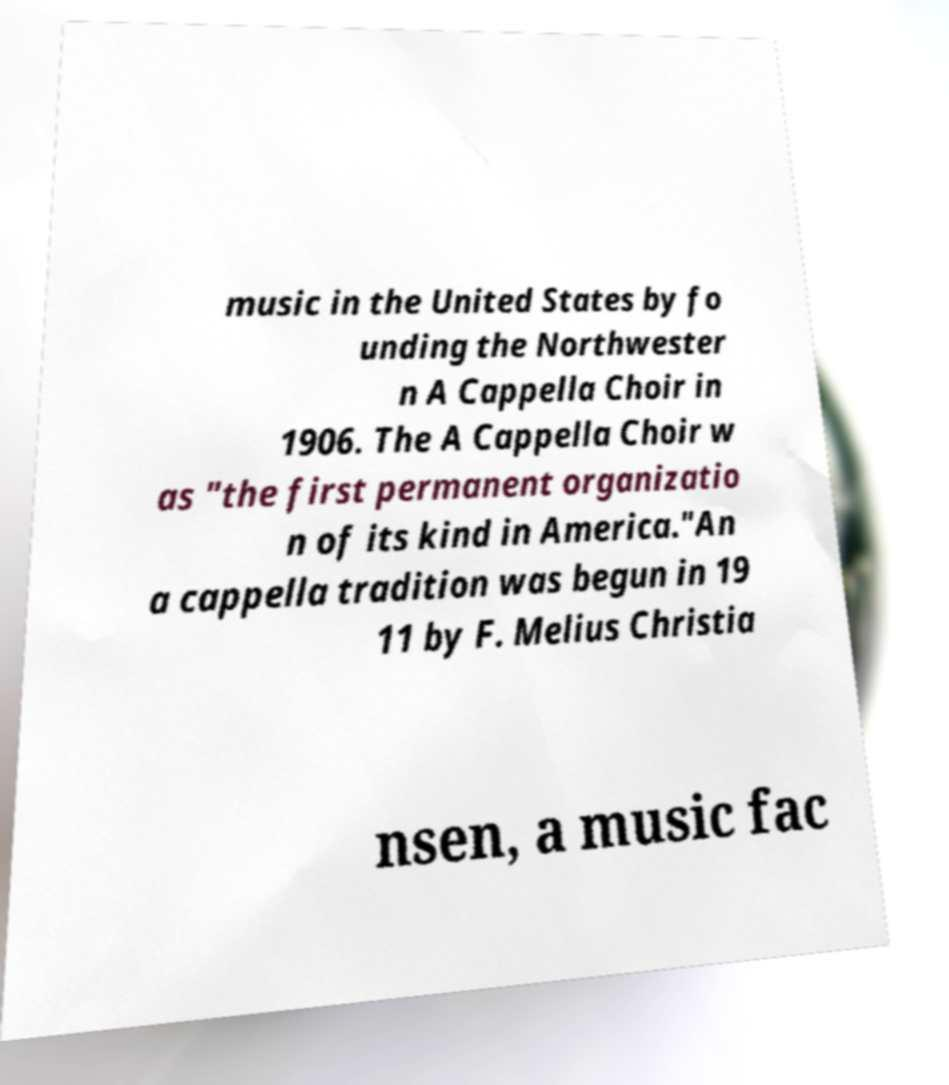I need the written content from this picture converted into text. Can you do that? music in the United States by fo unding the Northwester n A Cappella Choir in 1906. The A Cappella Choir w as "the first permanent organizatio n of its kind in America."An a cappella tradition was begun in 19 11 by F. Melius Christia nsen, a music fac 